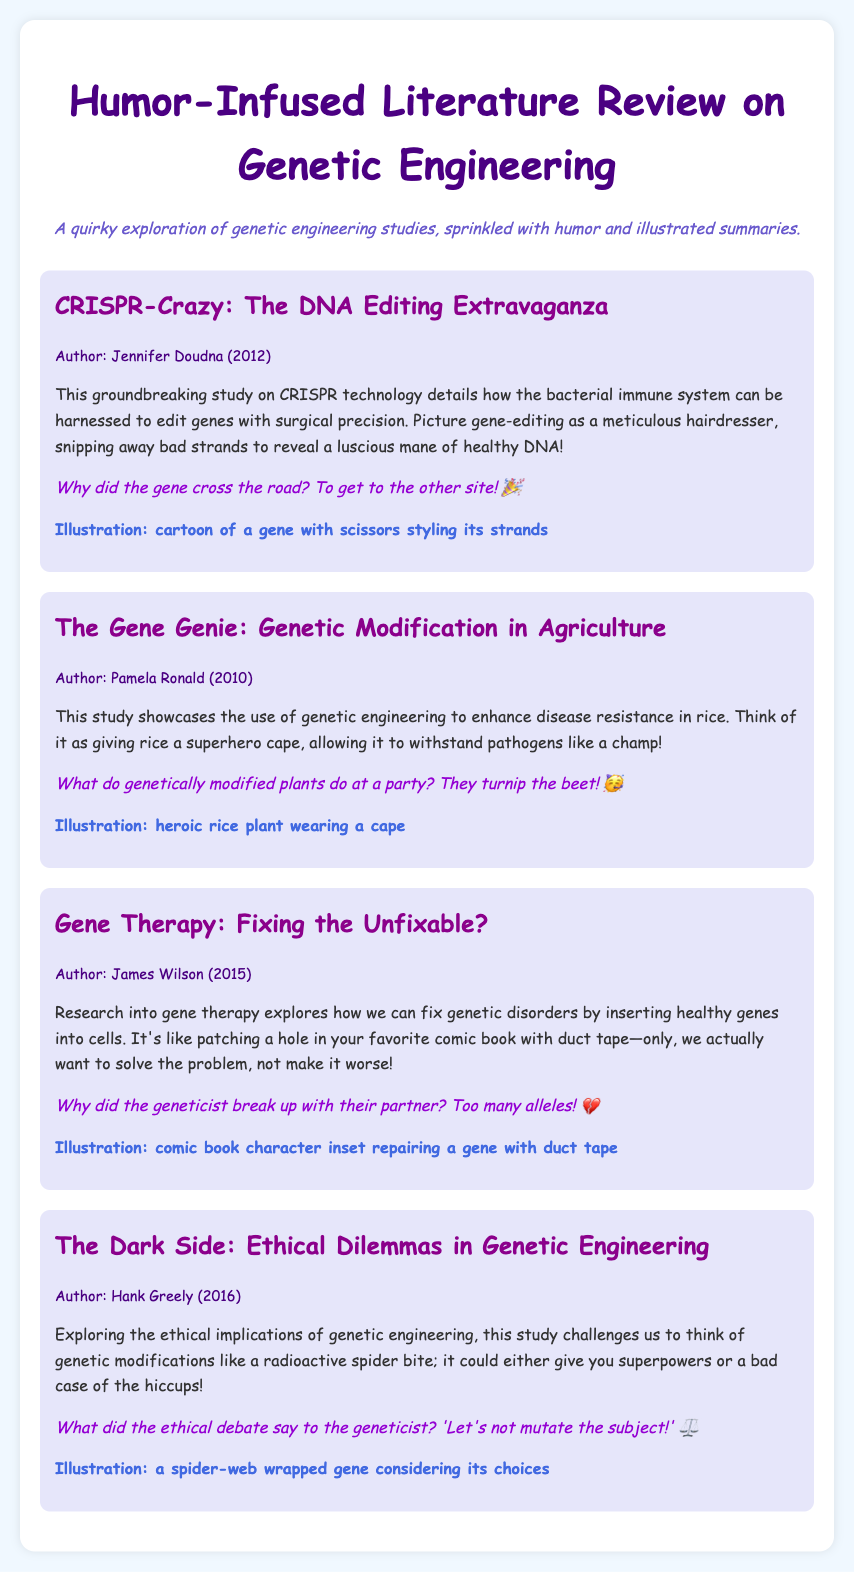What is the title of the first study? The title can be found in the first menu item detailing its contents.
Answer: CRISPR-Crazy: The DNA Editing Extravaganza Who is the author of "The Gene Genie"? The author is listed within the corresponding summary information section for that study.
Answer: Pamela Ronald What year was the study on gene therapy published? The publication year is included in the study info for that specific menu item.
Answer: 2015 What humorous line is associated with the study on CRISPR? Each menu item includes a humorous line related to the study discussed.
Answer: Why did the gene cross the road? To get to the other site! What is the theme of the fourth study? The theme can be derived from the title and summary describing the ethical considerations in genetic engineering.
Answer: Ethical Dilemmas in Genetic Engineering What visual representation is mentioned for the rice study? The illustration section for the study on genetic modification provides a description of its visual representation.
Answer: heroic rice plant wearing a cape Which humorous question relates to geneticists? The humor section in the gene therapy study contains a funny question addressing geneticists.
Answer: Why did the geneticist break up with their partner? Too many alleles! What color is the background of the document? The background color can be deduced from the style specifications in the document.
Answer: light blue 